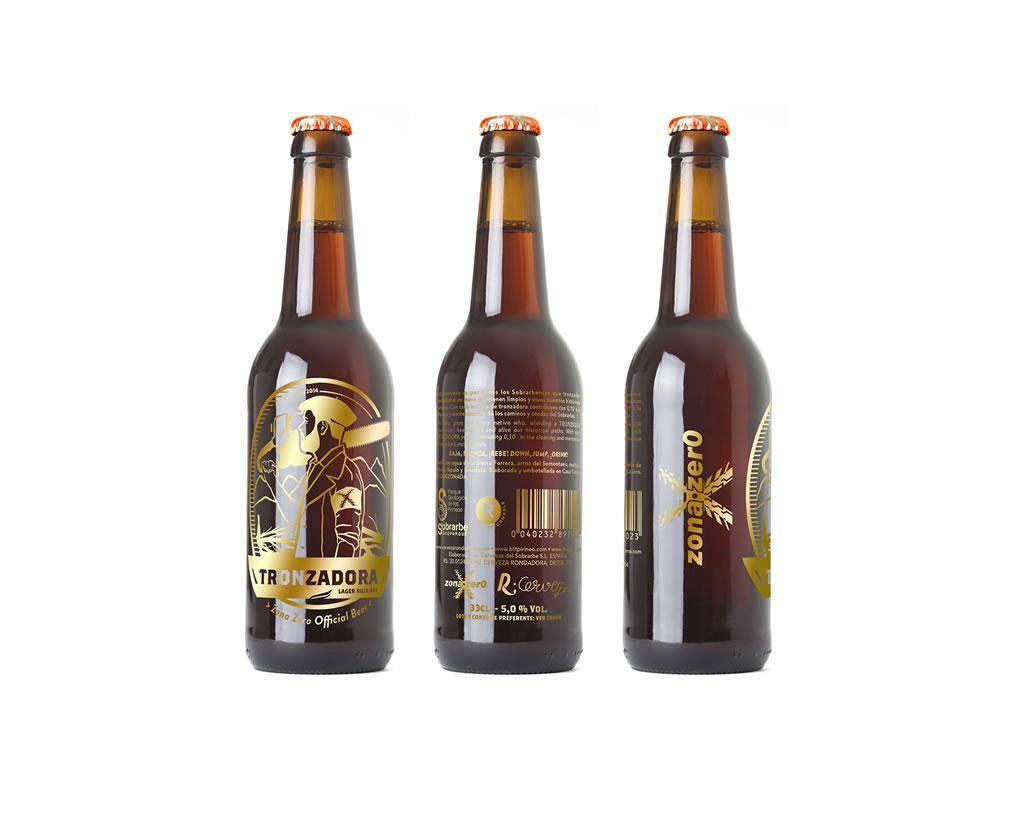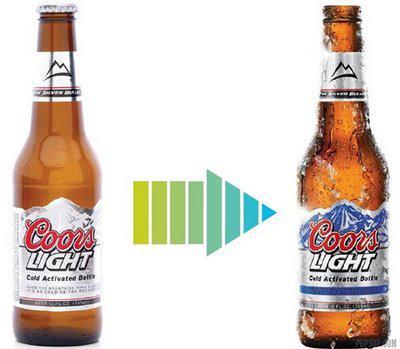The first image is the image on the left, the second image is the image on the right. Considering the images on both sides, is "One of the images shows exactly two bottles of beer." valid? Answer yes or no. Yes. 